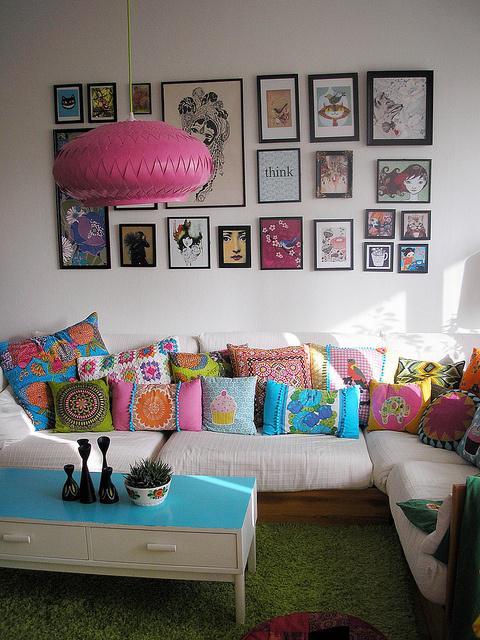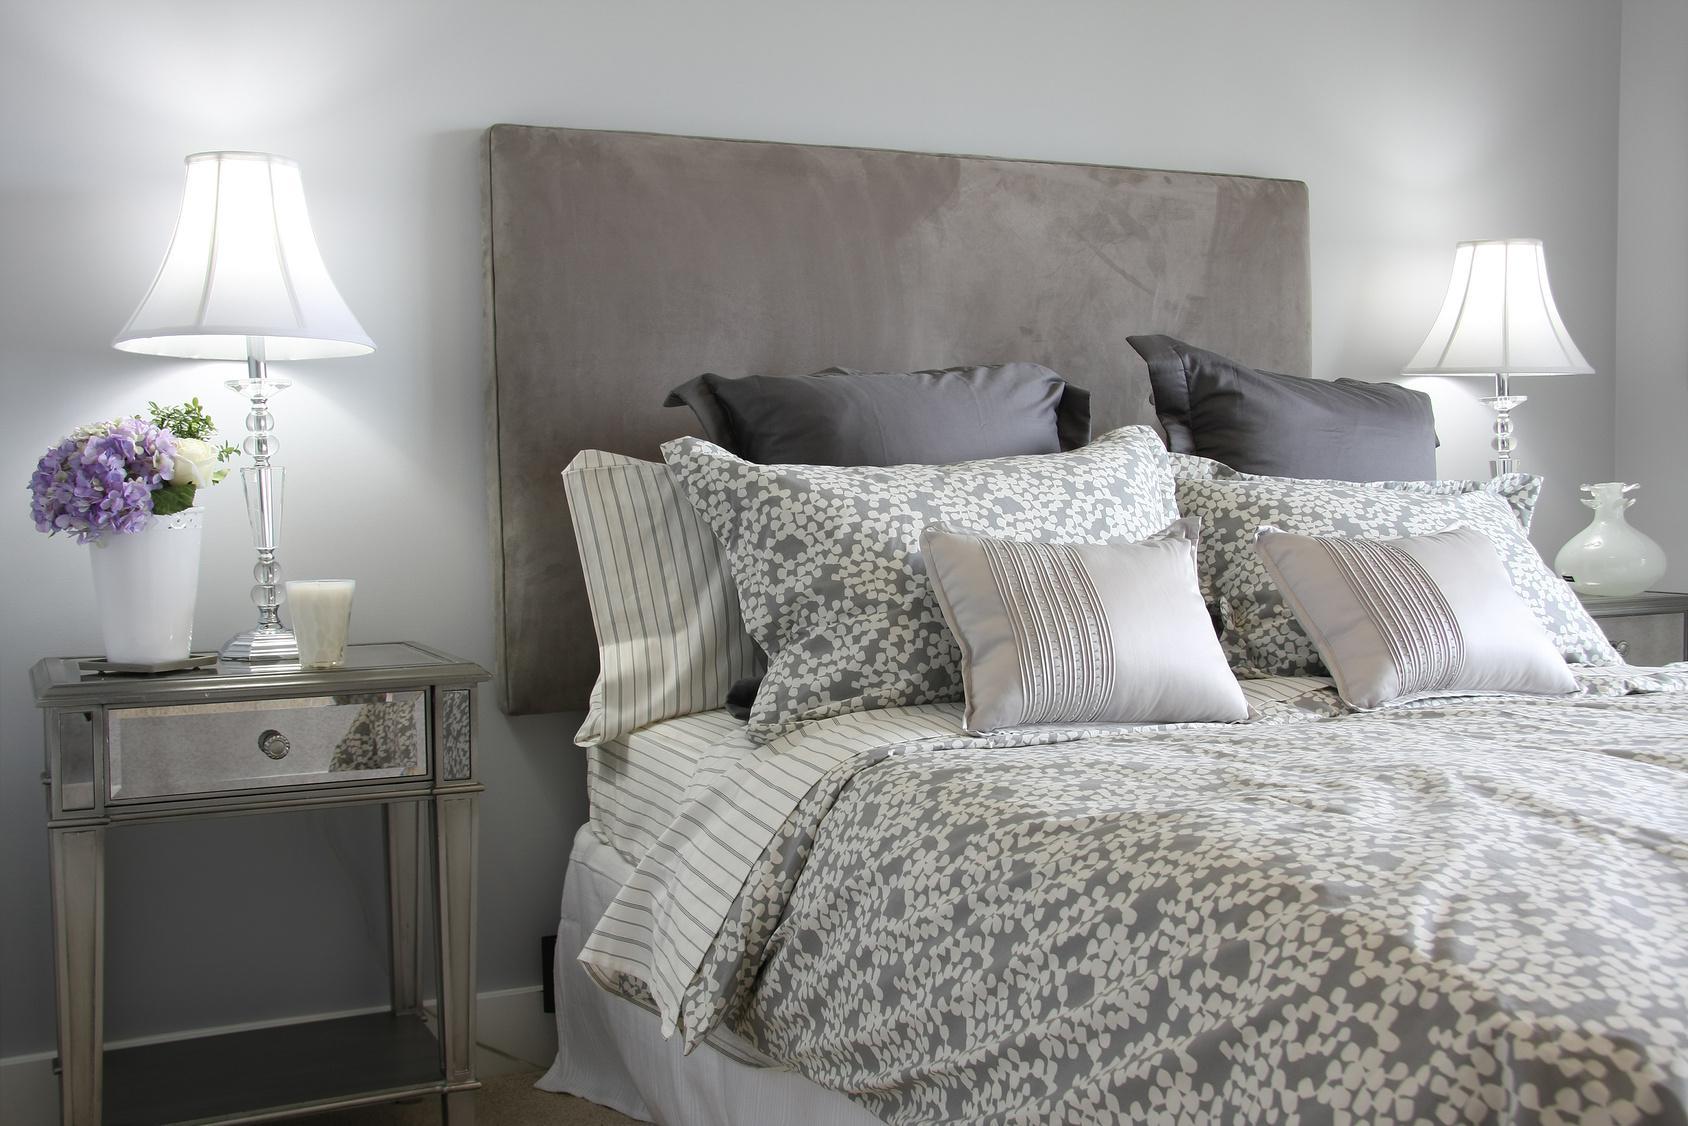The first image is the image on the left, the second image is the image on the right. For the images shown, is this caption "There are more than 5 frames on the wall in the image on the left." true? Answer yes or no. Yes. 